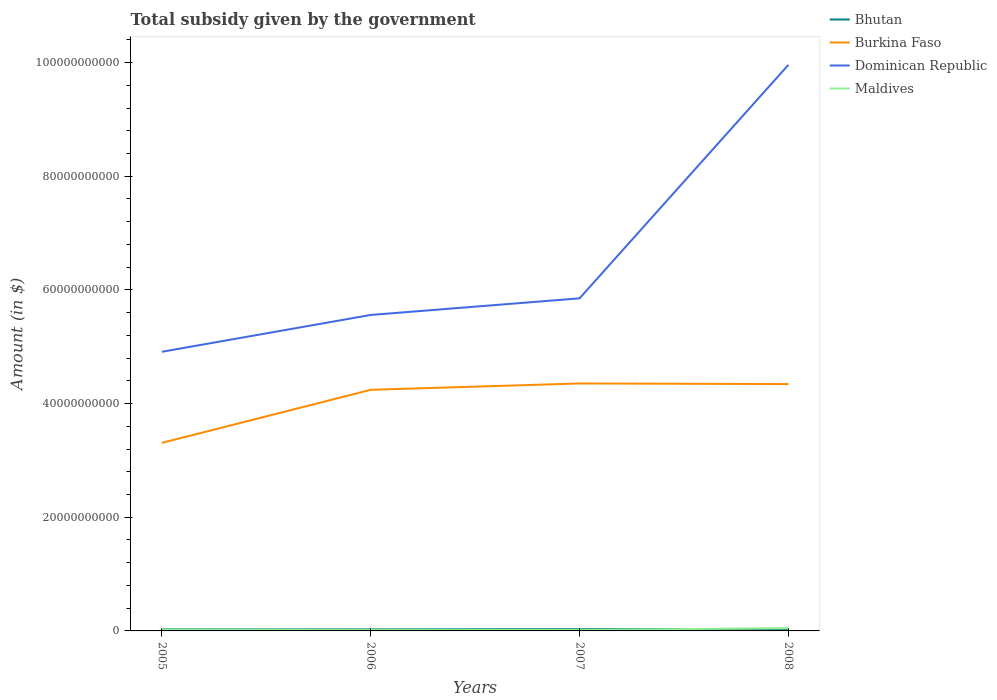How many different coloured lines are there?
Your answer should be very brief. 4. Does the line corresponding to Bhutan intersect with the line corresponding to Burkina Faso?
Make the answer very short. No. Is the number of lines equal to the number of legend labels?
Provide a short and direct response. Yes. Across all years, what is the maximum total revenue collected by the government in Burkina Faso?
Make the answer very short. 3.31e+1. What is the total total revenue collected by the government in Dominican Republic in the graph?
Make the answer very short. -9.40e+09. What is the difference between the highest and the second highest total revenue collected by the government in Burkina Faso?
Your response must be concise. 1.05e+1. What is the difference between the highest and the lowest total revenue collected by the government in Burkina Faso?
Provide a short and direct response. 3. How many years are there in the graph?
Your answer should be compact. 4. What is the difference between two consecutive major ticks on the Y-axis?
Your answer should be compact. 2.00e+1. Does the graph contain grids?
Your answer should be very brief. No. Where does the legend appear in the graph?
Your answer should be compact. Top right. How many legend labels are there?
Offer a terse response. 4. How are the legend labels stacked?
Your answer should be very brief. Vertical. What is the title of the graph?
Give a very brief answer. Total subsidy given by the government. Does "Iran" appear as one of the legend labels in the graph?
Offer a very short reply. No. What is the label or title of the Y-axis?
Provide a short and direct response. Amount (in $). What is the Amount (in $) in Bhutan in 2005?
Offer a terse response. 2.78e+08. What is the Amount (in $) of Burkina Faso in 2005?
Provide a succinct answer. 3.31e+1. What is the Amount (in $) of Dominican Republic in 2005?
Your response must be concise. 4.91e+1. What is the Amount (in $) in Maldives in 2005?
Provide a succinct answer. 2.28e+08. What is the Amount (in $) of Bhutan in 2006?
Offer a very short reply. 2.71e+08. What is the Amount (in $) of Burkina Faso in 2006?
Your answer should be very brief. 4.24e+1. What is the Amount (in $) of Dominican Republic in 2006?
Your answer should be very brief. 5.56e+1. What is the Amount (in $) in Maldives in 2006?
Offer a terse response. 1.50e+08. What is the Amount (in $) in Bhutan in 2007?
Give a very brief answer. 3.05e+08. What is the Amount (in $) in Burkina Faso in 2007?
Offer a terse response. 4.35e+1. What is the Amount (in $) of Dominican Republic in 2007?
Make the answer very short. 5.85e+1. What is the Amount (in $) of Maldives in 2007?
Provide a short and direct response. 1.68e+08. What is the Amount (in $) in Bhutan in 2008?
Give a very brief answer. 3.60e+08. What is the Amount (in $) of Burkina Faso in 2008?
Provide a short and direct response. 4.34e+1. What is the Amount (in $) in Dominican Republic in 2008?
Provide a short and direct response. 9.96e+1. What is the Amount (in $) of Maldives in 2008?
Keep it short and to the point. 4.79e+08. Across all years, what is the maximum Amount (in $) in Bhutan?
Provide a short and direct response. 3.60e+08. Across all years, what is the maximum Amount (in $) in Burkina Faso?
Provide a succinct answer. 4.35e+1. Across all years, what is the maximum Amount (in $) of Dominican Republic?
Your response must be concise. 9.96e+1. Across all years, what is the maximum Amount (in $) of Maldives?
Make the answer very short. 4.79e+08. Across all years, what is the minimum Amount (in $) of Bhutan?
Offer a very short reply. 2.71e+08. Across all years, what is the minimum Amount (in $) in Burkina Faso?
Provide a succinct answer. 3.31e+1. Across all years, what is the minimum Amount (in $) in Dominican Republic?
Keep it short and to the point. 4.91e+1. Across all years, what is the minimum Amount (in $) of Maldives?
Your answer should be very brief. 1.50e+08. What is the total Amount (in $) of Bhutan in the graph?
Give a very brief answer. 1.21e+09. What is the total Amount (in $) in Burkina Faso in the graph?
Ensure brevity in your answer.  1.62e+11. What is the total Amount (in $) in Dominican Republic in the graph?
Ensure brevity in your answer.  2.63e+11. What is the total Amount (in $) of Maldives in the graph?
Your response must be concise. 1.02e+09. What is the difference between the Amount (in $) of Bhutan in 2005 and that in 2006?
Ensure brevity in your answer.  7.73e+06. What is the difference between the Amount (in $) in Burkina Faso in 2005 and that in 2006?
Offer a very short reply. -9.33e+09. What is the difference between the Amount (in $) in Dominican Republic in 2005 and that in 2006?
Ensure brevity in your answer.  -6.48e+09. What is the difference between the Amount (in $) in Maldives in 2005 and that in 2006?
Offer a terse response. 7.77e+07. What is the difference between the Amount (in $) of Bhutan in 2005 and that in 2007?
Ensure brevity in your answer.  -2.63e+07. What is the difference between the Amount (in $) in Burkina Faso in 2005 and that in 2007?
Offer a terse response. -1.05e+1. What is the difference between the Amount (in $) in Dominican Republic in 2005 and that in 2007?
Offer a very short reply. -9.40e+09. What is the difference between the Amount (in $) in Maldives in 2005 and that in 2007?
Ensure brevity in your answer.  5.92e+07. What is the difference between the Amount (in $) of Bhutan in 2005 and that in 2008?
Keep it short and to the point. -8.19e+07. What is the difference between the Amount (in $) of Burkina Faso in 2005 and that in 2008?
Provide a succinct answer. -1.03e+1. What is the difference between the Amount (in $) of Dominican Republic in 2005 and that in 2008?
Ensure brevity in your answer.  -5.05e+1. What is the difference between the Amount (in $) of Maldives in 2005 and that in 2008?
Ensure brevity in your answer.  -2.52e+08. What is the difference between the Amount (in $) in Bhutan in 2006 and that in 2007?
Provide a short and direct response. -3.40e+07. What is the difference between the Amount (in $) of Burkina Faso in 2006 and that in 2007?
Provide a succinct answer. -1.12e+09. What is the difference between the Amount (in $) of Dominican Republic in 2006 and that in 2007?
Make the answer very short. -2.92e+09. What is the difference between the Amount (in $) in Maldives in 2006 and that in 2007?
Make the answer very short. -1.85e+07. What is the difference between the Amount (in $) of Bhutan in 2006 and that in 2008?
Make the answer very short. -8.96e+07. What is the difference between the Amount (in $) of Burkina Faso in 2006 and that in 2008?
Make the answer very short. -1.01e+09. What is the difference between the Amount (in $) of Dominican Republic in 2006 and that in 2008?
Provide a succinct answer. -4.40e+1. What is the difference between the Amount (in $) of Maldives in 2006 and that in 2008?
Offer a very short reply. -3.29e+08. What is the difference between the Amount (in $) of Bhutan in 2007 and that in 2008?
Your answer should be very brief. -5.56e+07. What is the difference between the Amount (in $) of Burkina Faso in 2007 and that in 2008?
Offer a very short reply. 1.12e+08. What is the difference between the Amount (in $) of Dominican Republic in 2007 and that in 2008?
Your answer should be very brief. -4.11e+1. What is the difference between the Amount (in $) in Maldives in 2007 and that in 2008?
Offer a terse response. -3.11e+08. What is the difference between the Amount (in $) in Bhutan in 2005 and the Amount (in $) in Burkina Faso in 2006?
Offer a very short reply. -4.21e+1. What is the difference between the Amount (in $) of Bhutan in 2005 and the Amount (in $) of Dominican Republic in 2006?
Your answer should be very brief. -5.53e+1. What is the difference between the Amount (in $) in Bhutan in 2005 and the Amount (in $) in Maldives in 2006?
Your answer should be compact. 1.28e+08. What is the difference between the Amount (in $) of Burkina Faso in 2005 and the Amount (in $) of Dominican Republic in 2006?
Offer a very short reply. -2.25e+1. What is the difference between the Amount (in $) in Burkina Faso in 2005 and the Amount (in $) in Maldives in 2006?
Make the answer very short. 3.29e+1. What is the difference between the Amount (in $) of Dominican Republic in 2005 and the Amount (in $) of Maldives in 2006?
Ensure brevity in your answer.  4.90e+1. What is the difference between the Amount (in $) of Bhutan in 2005 and the Amount (in $) of Burkina Faso in 2007?
Your answer should be very brief. -4.33e+1. What is the difference between the Amount (in $) of Bhutan in 2005 and the Amount (in $) of Dominican Republic in 2007?
Your answer should be very brief. -5.82e+1. What is the difference between the Amount (in $) in Bhutan in 2005 and the Amount (in $) in Maldives in 2007?
Keep it short and to the point. 1.10e+08. What is the difference between the Amount (in $) in Burkina Faso in 2005 and the Amount (in $) in Dominican Republic in 2007?
Your answer should be compact. -2.54e+1. What is the difference between the Amount (in $) of Burkina Faso in 2005 and the Amount (in $) of Maldives in 2007?
Your answer should be very brief. 3.29e+1. What is the difference between the Amount (in $) in Dominican Republic in 2005 and the Amount (in $) in Maldives in 2007?
Keep it short and to the point. 4.89e+1. What is the difference between the Amount (in $) of Bhutan in 2005 and the Amount (in $) of Burkina Faso in 2008?
Give a very brief answer. -4.32e+1. What is the difference between the Amount (in $) of Bhutan in 2005 and the Amount (in $) of Dominican Republic in 2008?
Offer a terse response. -9.93e+1. What is the difference between the Amount (in $) of Bhutan in 2005 and the Amount (in $) of Maldives in 2008?
Your answer should be very brief. -2.01e+08. What is the difference between the Amount (in $) of Burkina Faso in 2005 and the Amount (in $) of Dominican Republic in 2008?
Your answer should be very brief. -6.65e+1. What is the difference between the Amount (in $) in Burkina Faso in 2005 and the Amount (in $) in Maldives in 2008?
Make the answer very short. 3.26e+1. What is the difference between the Amount (in $) in Dominican Republic in 2005 and the Amount (in $) in Maldives in 2008?
Your answer should be compact. 4.86e+1. What is the difference between the Amount (in $) of Bhutan in 2006 and the Amount (in $) of Burkina Faso in 2007?
Your answer should be compact. -4.33e+1. What is the difference between the Amount (in $) in Bhutan in 2006 and the Amount (in $) in Dominican Republic in 2007?
Your response must be concise. -5.82e+1. What is the difference between the Amount (in $) of Bhutan in 2006 and the Amount (in $) of Maldives in 2007?
Offer a terse response. 1.02e+08. What is the difference between the Amount (in $) of Burkina Faso in 2006 and the Amount (in $) of Dominican Republic in 2007?
Offer a terse response. -1.61e+1. What is the difference between the Amount (in $) of Burkina Faso in 2006 and the Amount (in $) of Maldives in 2007?
Offer a very short reply. 4.23e+1. What is the difference between the Amount (in $) in Dominican Republic in 2006 and the Amount (in $) in Maldives in 2007?
Give a very brief answer. 5.54e+1. What is the difference between the Amount (in $) in Bhutan in 2006 and the Amount (in $) in Burkina Faso in 2008?
Make the answer very short. -4.32e+1. What is the difference between the Amount (in $) of Bhutan in 2006 and the Amount (in $) of Dominican Republic in 2008?
Ensure brevity in your answer.  -9.93e+1. What is the difference between the Amount (in $) in Bhutan in 2006 and the Amount (in $) in Maldives in 2008?
Your response must be concise. -2.09e+08. What is the difference between the Amount (in $) of Burkina Faso in 2006 and the Amount (in $) of Dominican Republic in 2008?
Your response must be concise. -5.72e+1. What is the difference between the Amount (in $) of Burkina Faso in 2006 and the Amount (in $) of Maldives in 2008?
Give a very brief answer. 4.19e+1. What is the difference between the Amount (in $) in Dominican Republic in 2006 and the Amount (in $) in Maldives in 2008?
Provide a succinct answer. 5.51e+1. What is the difference between the Amount (in $) of Bhutan in 2007 and the Amount (in $) of Burkina Faso in 2008?
Your answer should be very brief. -4.31e+1. What is the difference between the Amount (in $) in Bhutan in 2007 and the Amount (in $) in Dominican Republic in 2008?
Give a very brief answer. -9.93e+1. What is the difference between the Amount (in $) in Bhutan in 2007 and the Amount (in $) in Maldives in 2008?
Keep it short and to the point. -1.75e+08. What is the difference between the Amount (in $) in Burkina Faso in 2007 and the Amount (in $) in Dominican Republic in 2008?
Your response must be concise. -5.61e+1. What is the difference between the Amount (in $) in Burkina Faso in 2007 and the Amount (in $) in Maldives in 2008?
Your answer should be compact. 4.31e+1. What is the difference between the Amount (in $) in Dominican Republic in 2007 and the Amount (in $) in Maldives in 2008?
Provide a short and direct response. 5.80e+1. What is the average Amount (in $) of Bhutan per year?
Your answer should be compact. 3.03e+08. What is the average Amount (in $) in Burkina Faso per year?
Offer a terse response. 4.06e+1. What is the average Amount (in $) in Dominican Republic per year?
Ensure brevity in your answer.  6.57e+1. What is the average Amount (in $) of Maldives per year?
Make the answer very short. 2.56e+08. In the year 2005, what is the difference between the Amount (in $) of Bhutan and Amount (in $) of Burkina Faso?
Your answer should be very brief. -3.28e+1. In the year 2005, what is the difference between the Amount (in $) of Bhutan and Amount (in $) of Dominican Republic?
Your response must be concise. -4.88e+1. In the year 2005, what is the difference between the Amount (in $) in Bhutan and Amount (in $) in Maldives?
Your response must be concise. 5.07e+07. In the year 2005, what is the difference between the Amount (in $) in Burkina Faso and Amount (in $) in Dominican Republic?
Your answer should be very brief. -1.60e+1. In the year 2005, what is the difference between the Amount (in $) of Burkina Faso and Amount (in $) of Maldives?
Offer a very short reply. 3.29e+1. In the year 2005, what is the difference between the Amount (in $) in Dominican Republic and Amount (in $) in Maldives?
Ensure brevity in your answer.  4.89e+1. In the year 2006, what is the difference between the Amount (in $) of Bhutan and Amount (in $) of Burkina Faso?
Offer a terse response. -4.22e+1. In the year 2006, what is the difference between the Amount (in $) in Bhutan and Amount (in $) in Dominican Republic?
Provide a succinct answer. -5.53e+1. In the year 2006, what is the difference between the Amount (in $) of Bhutan and Amount (in $) of Maldives?
Make the answer very short. 1.21e+08. In the year 2006, what is the difference between the Amount (in $) of Burkina Faso and Amount (in $) of Dominican Republic?
Provide a succinct answer. -1.32e+1. In the year 2006, what is the difference between the Amount (in $) of Burkina Faso and Amount (in $) of Maldives?
Offer a terse response. 4.23e+1. In the year 2006, what is the difference between the Amount (in $) in Dominican Republic and Amount (in $) in Maldives?
Provide a succinct answer. 5.54e+1. In the year 2007, what is the difference between the Amount (in $) in Bhutan and Amount (in $) in Burkina Faso?
Offer a terse response. -4.32e+1. In the year 2007, what is the difference between the Amount (in $) of Bhutan and Amount (in $) of Dominican Republic?
Provide a succinct answer. -5.82e+1. In the year 2007, what is the difference between the Amount (in $) in Bhutan and Amount (in $) in Maldives?
Keep it short and to the point. 1.36e+08. In the year 2007, what is the difference between the Amount (in $) in Burkina Faso and Amount (in $) in Dominican Republic?
Ensure brevity in your answer.  -1.50e+1. In the year 2007, what is the difference between the Amount (in $) of Burkina Faso and Amount (in $) of Maldives?
Give a very brief answer. 4.34e+1. In the year 2007, what is the difference between the Amount (in $) in Dominican Republic and Amount (in $) in Maldives?
Offer a terse response. 5.84e+1. In the year 2008, what is the difference between the Amount (in $) of Bhutan and Amount (in $) of Burkina Faso?
Offer a terse response. -4.31e+1. In the year 2008, what is the difference between the Amount (in $) in Bhutan and Amount (in $) in Dominican Republic?
Your answer should be very brief. -9.92e+1. In the year 2008, what is the difference between the Amount (in $) of Bhutan and Amount (in $) of Maldives?
Your response must be concise. -1.19e+08. In the year 2008, what is the difference between the Amount (in $) of Burkina Faso and Amount (in $) of Dominican Republic?
Ensure brevity in your answer.  -5.62e+1. In the year 2008, what is the difference between the Amount (in $) in Burkina Faso and Amount (in $) in Maldives?
Make the answer very short. 4.30e+1. In the year 2008, what is the difference between the Amount (in $) in Dominican Republic and Amount (in $) in Maldives?
Offer a terse response. 9.91e+1. What is the ratio of the Amount (in $) of Bhutan in 2005 to that in 2006?
Provide a short and direct response. 1.03. What is the ratio of the Amount (in $) in Burkina Faso in 2005 to that in 2006?
Offer a very short reply. 0.78. What is the ratio of the Amount (in $) of Dominican Republic in 2005 to that in 2006?
Give a very brief answer. 0.88. What is the ratio of the Amount (in $) of Maldives in 2005 to that in 2006?
Your response must be concise. 1.52. What is the ratio of the Amount (in $) in Bhutan in 2005 to that in 2007?
Keep it short and to the point. 0.91. What is the ratio of the Amount (in $) in Burkina Faso in 2005 to that in 2007?
Keep it short and to the point. 0.76. What is the ratio of the Amount (in $) in Dominican Republic in 2005 to that in 2007?
Offer a very short reply. 0.84. What is the ratio of the Amount (in $) of Maldives in 2005 to that in 2007?
Give a very brief answer. 1.35. What is the ratio of the Amount (in $) in Bhutan in 2005 to that in 2008?
Your answer should be very brief. 0.77. What is the ratio of the Amount (in $) in Burkina Faso in 2005 to that in 2008?
Provide a short and direct response. 0.76. What is the ratio of the Amount (in $) in Dominican Republic in 2005 to that in 2008?
Offer a terse response. 0.49. What is the ratio of the Amount (in $) of Maldives in 2005 to that in 2008?
Give a very brief answer. 0.47. What is the ratio of the Amount (in $) of Bhutan in 2006 to that in 2007?
Keep it short and to the point. 0.89. What is the ratio of the Amount (in $) of Burkina Faso in 2006 to that in 2007?
Your answer should be very brief. 0.97. What is the ratio of the Amount (in $) in Maldives in 2006 to that in 2007?
Provide a short and direct response. 0.89. What is the ratio of the Amount (in $) of Bhutan in 2006 to that in 2008?
Ensure brevity in your answer.  0.75. What is the ratio of the Amount (in $) in Burkina Faso in 2006 to that in 2008?
Provide a short and direct response. 0.98. What is the ratio of the Amount (in $) of Dominican Republic in 2006 to that in 2008?
Make the answer very short. 0.56. What is the ratio of the Amount (in $) of Maldives in 2006 to that in 2008?
Offer a terse response. 0.31. What is the ratio of the Amount (in $) in Bhutan in 2007 to that in 2008?
Make the answer very short. 0.85. What is the ratio of the Amount (in $) of Burkina Faso in 2007 to that in 2008?
Offer a terse response. 1. What is the ratio of the Amount (in $) of Dominican Republic in 2007 to that in 2008?
Give a very brief answer. 0.59. What is the ratio of the Amount (in $) in Maldives in 2007 to that in 2008?
Give a very brief answer. 0.35. What is the difference between the highest and the second highest Amount (in $) in Bhutan?
Provide a short and direct response. 5.56e+07. What is the difference between the highest and the second highest Amount (in $) in Burkina Faso?
Provide a short and direct response. 1.12e+08. What is the difference between the highest and the second highest Amount (in $) of Dominican Republic?
Offer a terse response. 4.11e+1. What is the difference between the highest and the second highest Amount (in $) of Maldives?
Keep it short and to the point. 2.52e+08. What is the difference between the highest and the lowest Amount (in $) of Bhutan?
Provide a succinct answer. 8.96e+07. What is the difference between the highest and the lowest Amount (in $) in Burkina Faso?
Give a very brief answer. 1.05e+1. What is the difference between the highest and the lowest Amount (in $) in Dominican Republic?
Ensure brevity in your answer.  5.05e+1. What is the difference between the highest and the lowest Amount (in $) in Maldives?
Provide a short and direct response. 3.29e+08. 